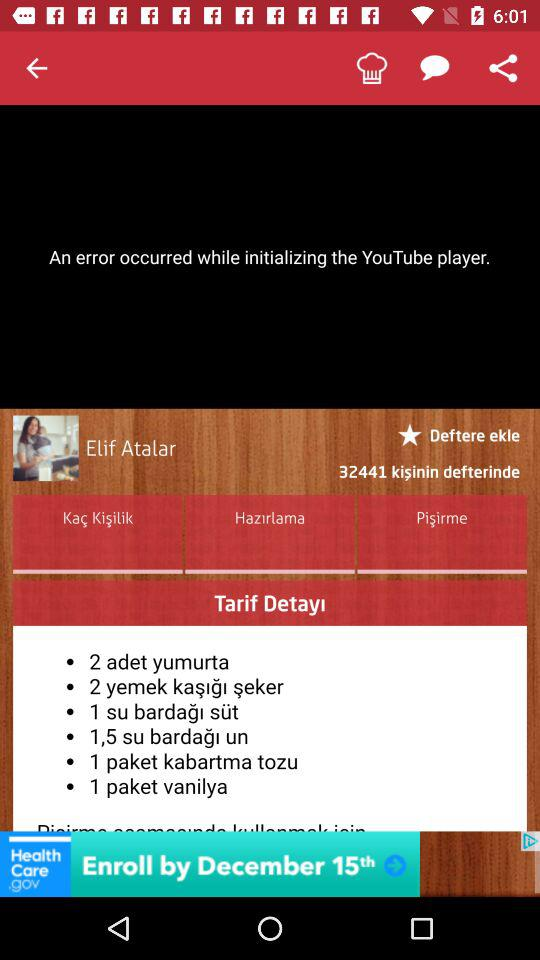What is the user name? The user name is Elif Atalar. 